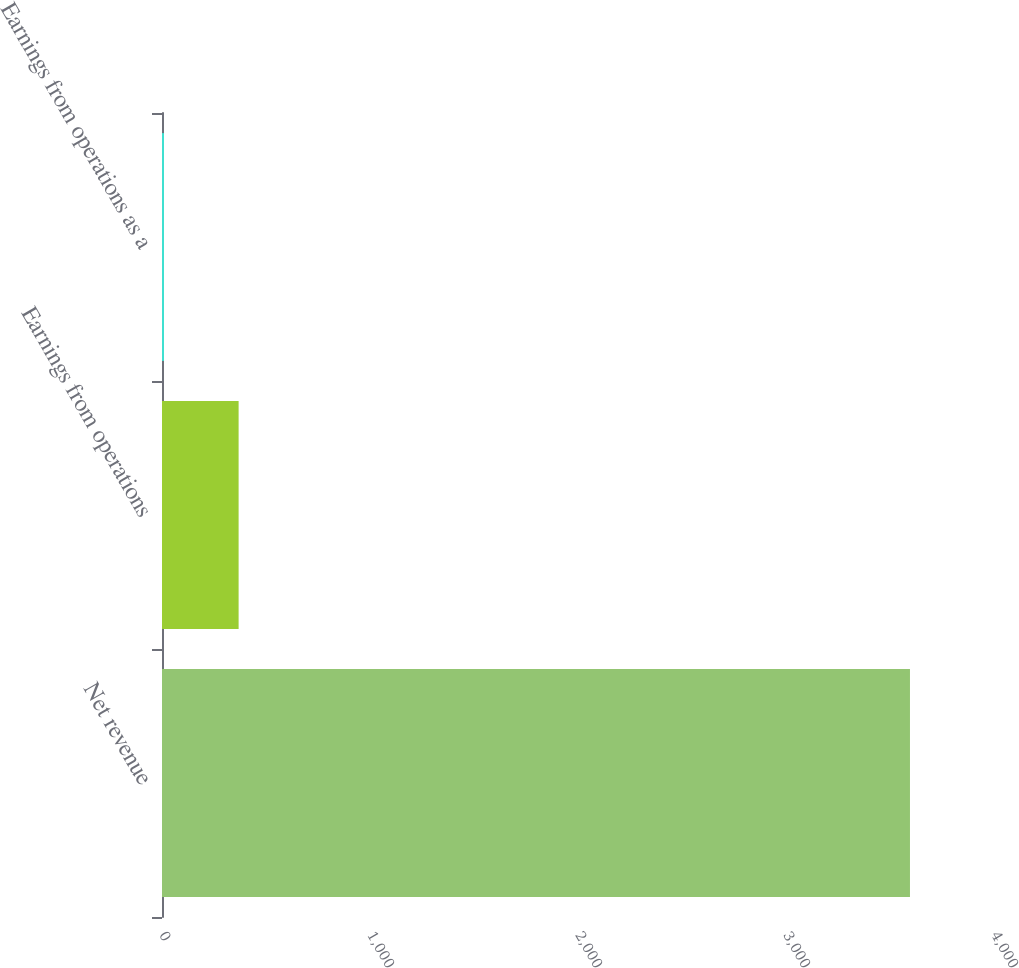Convert chart to OTSL. <chart><loc_0><loc_0><loc_500><loc_500><bar_chart><fcel>Net revenue<fcel>Earnings from operations<fcel>Earnings from operations as a<nl><fcel>3596<fcel>368.33<fcel>9.7<nl></chart> 